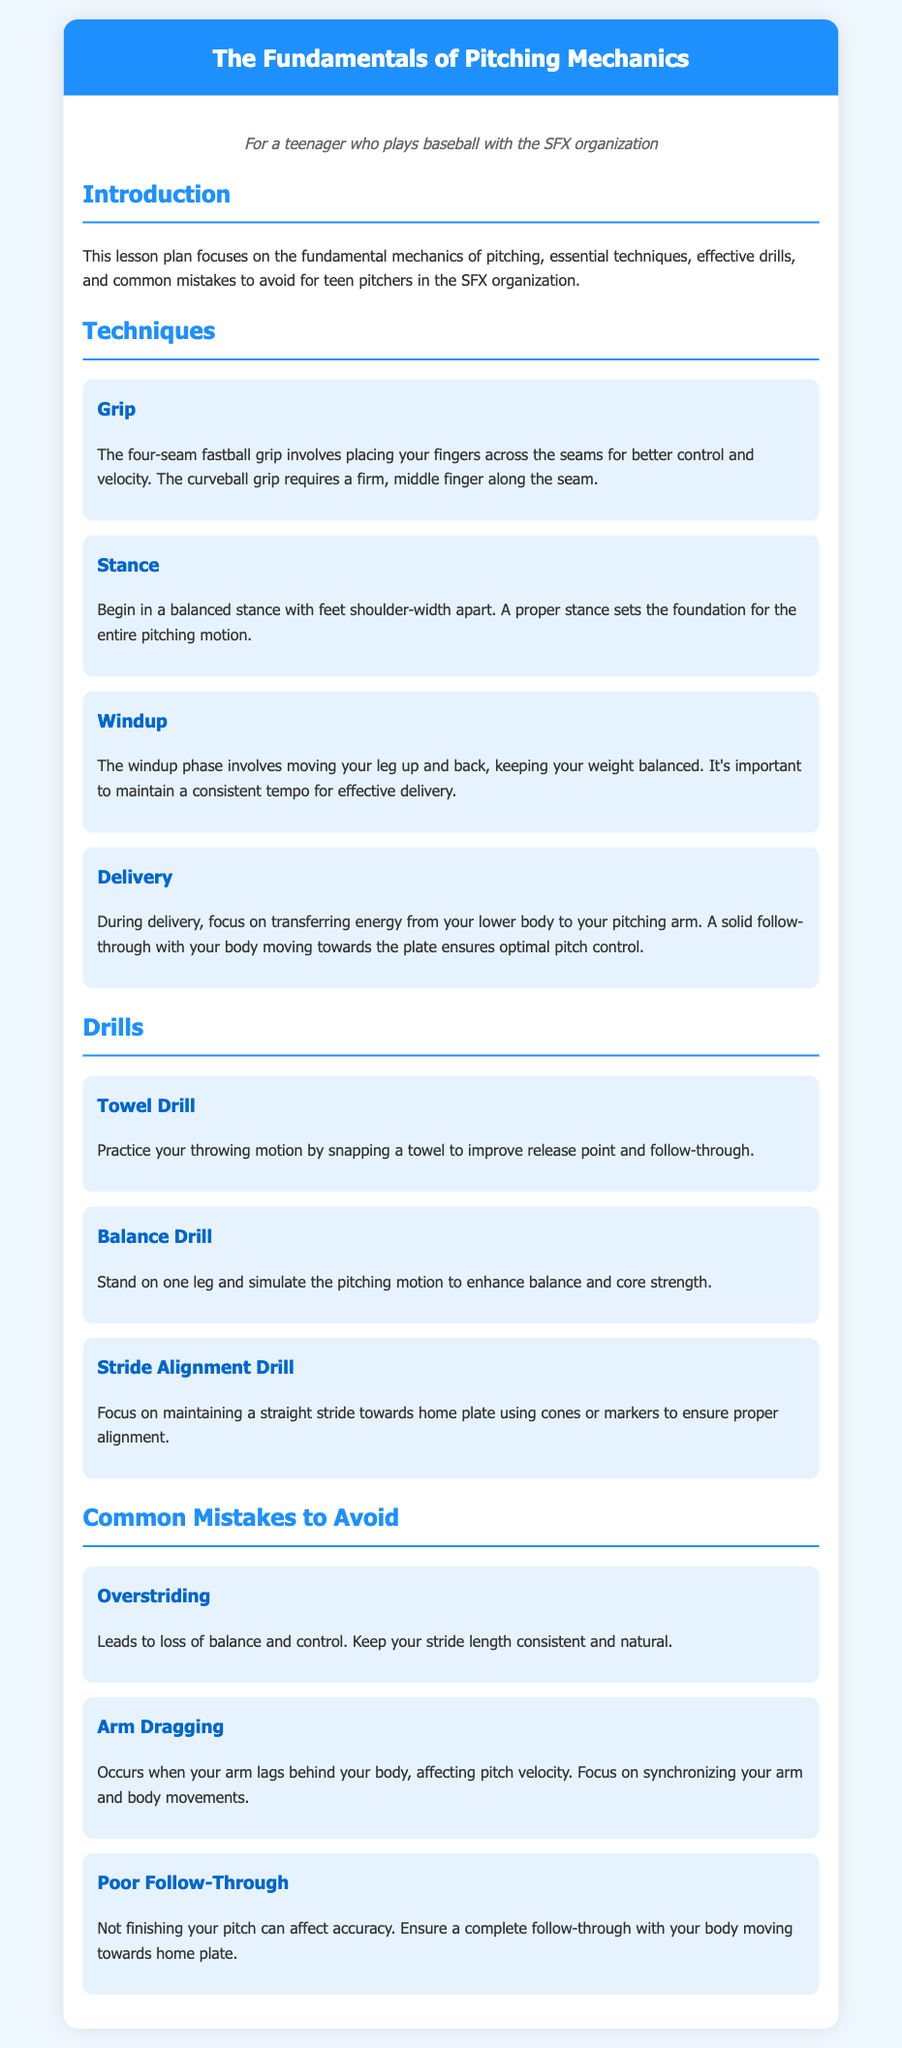What is the title of the lesson plan? The title of the lesson plan is the primary heading at the top of the document, stating the main topic covered.
Answer: The Fundamentals of Pitching Mechanics What is the focus of this lesson plan? The focus of the lesson plan is outlined in the introduction, summarizing the main topics discussed.
Answer: The fundamental mechanics of pitching What is the first technique mentioned? The first technique is listed under the Techniques section, highlighting an essential skill for pitching.
Answer: Grip What does the Towel Drill practice? The Towel Drill is described under the Drills section, detailing what skill it helps improve for pitchers.
Answer: Throwing motion What common mistake relates to balance? This mistake is found in the Common Mistakes section, highlighting an issue that affects a pitcher's performance.
Answer: Overstriding What is emphasized during the Delivery technique? Key aspects of the Delivery technique are detailed, explaining what focus is necessary to optimize the pitch.
Answer: Transferring energy Which drill enhances core strength? This drill is identified in the Drills section, focusing on improving a specific aspect of a pitcher's physical ability.
Answer: Balance Drill What mistake affects pitch velocity? This mistake is listed under the Common Mistakes section, indicating its impact on a pitcher's performance.
Answer: Arm Dragging How many drills are mentioned in the lesson plan? The total number of drills can be counted in the Drills section, providing a quantitative aspect of the lesson plan.
Answer: Three 